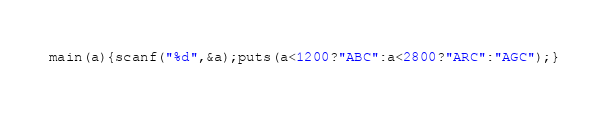Convert code to text. <code><loc_0><loc_0><loc_500><loc_500><_C_>main(a){scanf("%d",&a);puts(a<1200?"ABC":a<2800?"ARC":"AGC");}</code> 